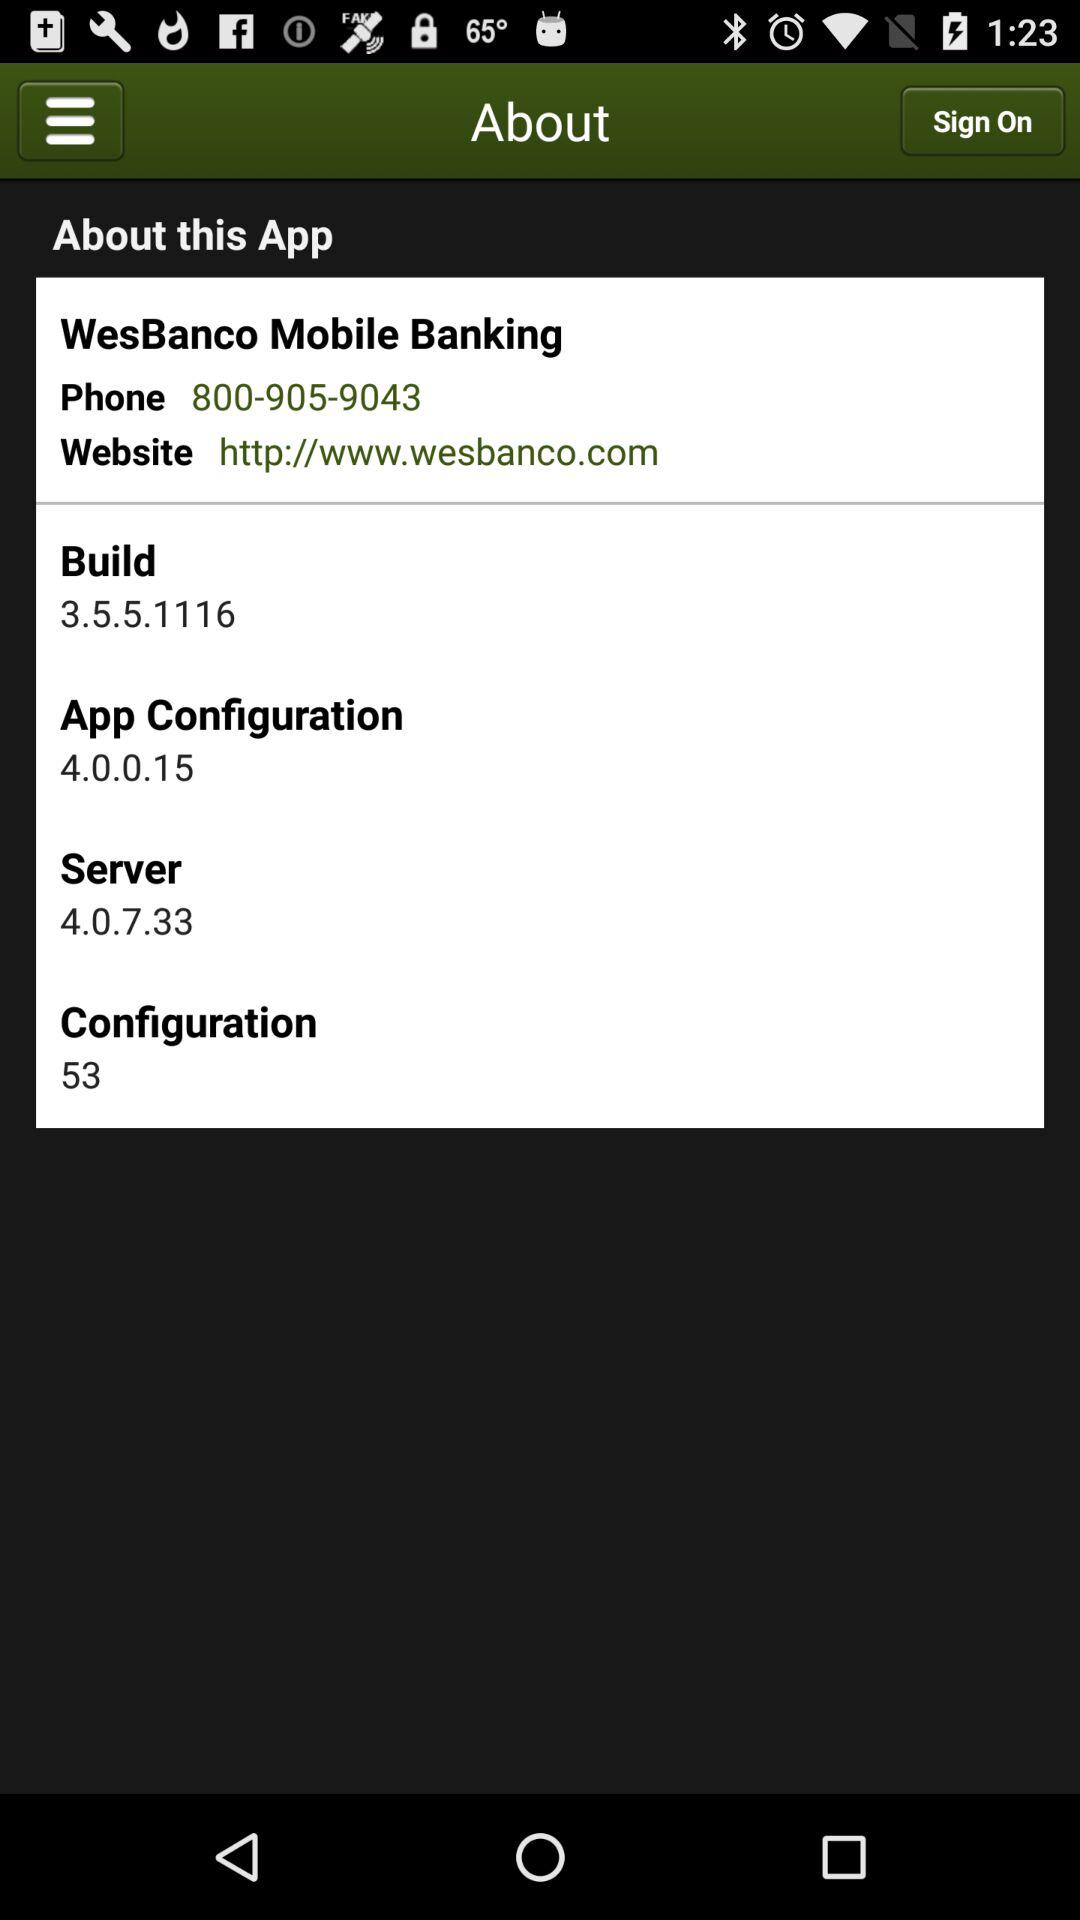What is the URL of the mentioned website? The URL is http://www.wesbanco.com. 